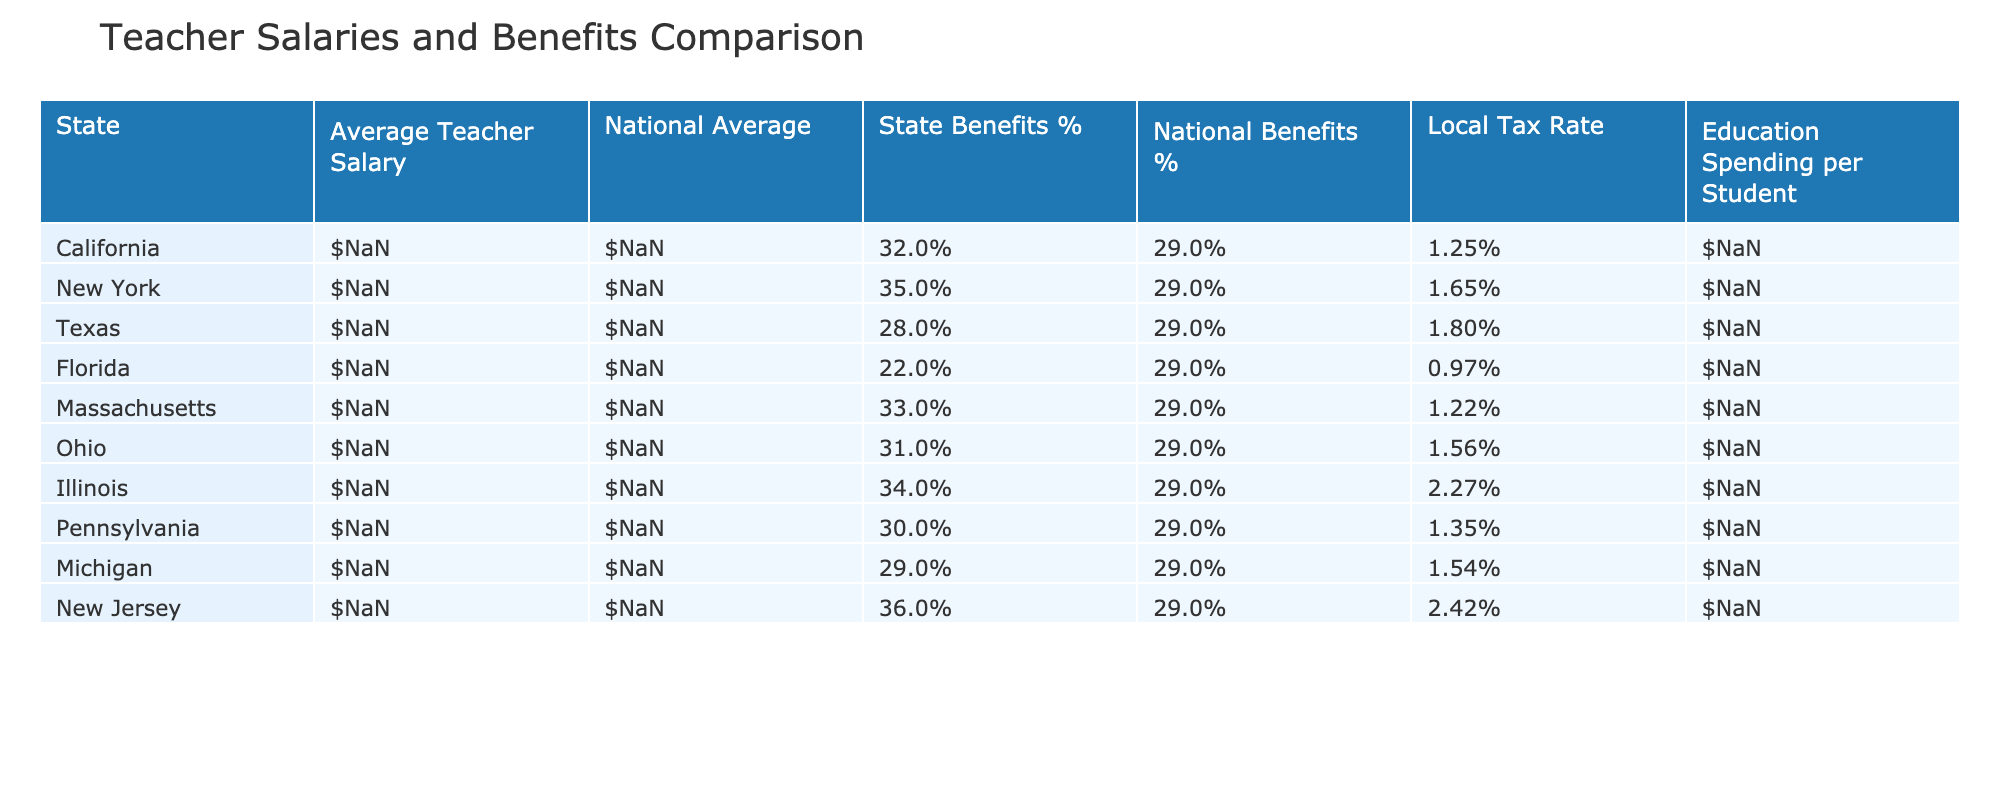What is the average teacher salary in California? The table lists California's average teacher salary directly as $85,400.
Answer: $85,400 Which state has the highest average teacher salary? By comparing the average salaries listed in the table, New York has the highest with $87,543.
Answer: New York What percentage of benefits do teachers in Massachusetts receive? The table shows Massachusetts with state benefits at 33%.
Answer: 33% Is the national average teacher salary higher than the average salary of Texas? The national average is $63,645, while Texas's average salary is $57,641, which means Texas's average is lower.
Answer: Yes What is the difference between the education spending per student in New York and Texas? New York's spending per student is $24,040, and Texas's is $9,606. The difference is $24,040 - $9,606 = $14,434.
Answer: $14,434 What is the average benefits percentage for teachers across the states provided? To find the average, add the state benefits percentages (32 + 35 + 28 + 22 + 33 + 31 + 34 + 30 + 29 + 36) =  306, and divide by 10 states, giving an average of 30.6%.
Answer: 30.6% Which state has a local tax rate that is lower than 1%? Looking through the table, only Florida has a local tax rate of 0.97%, making it the only state under 1%.
Answer: Florida Is it true that Illinois has a national benefits percentage that matches the national average? The national benefits percentage is 29%, and Illinois also has 29%, confirming they match.
Answer: Yes Which state has the highest benefits percentage in relation to the national average? New Jersey has the highest state benefits percentage at 36%, compared to the national average of 29%.
Answer: New Jersey If you were to rank the states by average teacher salary, what position does Ohio occupy? By sorting the average salaries from highest to lowest, Ohio ranks in 6th position with $59,713.
Answer: 6th position 